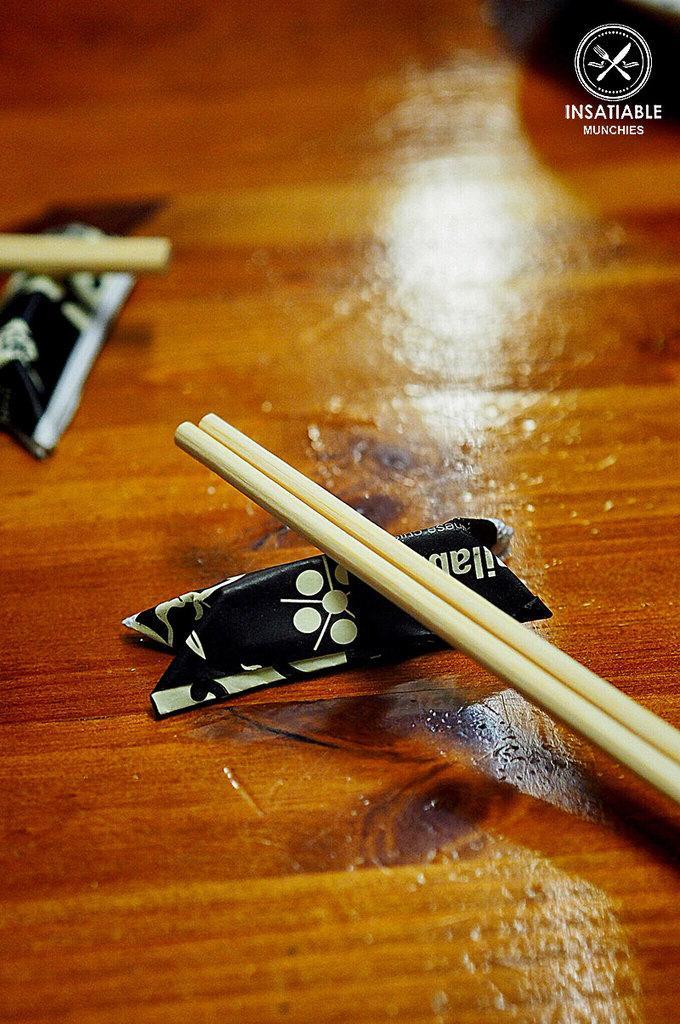Please provide a concise description of this image. We can see chopsticks and a paper on the table. 